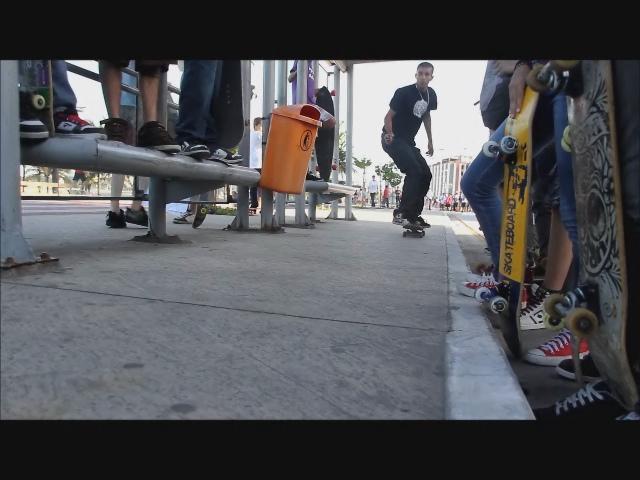What sport is the guy doing?
Short answer required. Skateboarding. What color is the trash can?
Short answer required. Orange. Is he skating boarding on the sidewalk?
Be succinct. Yes. 